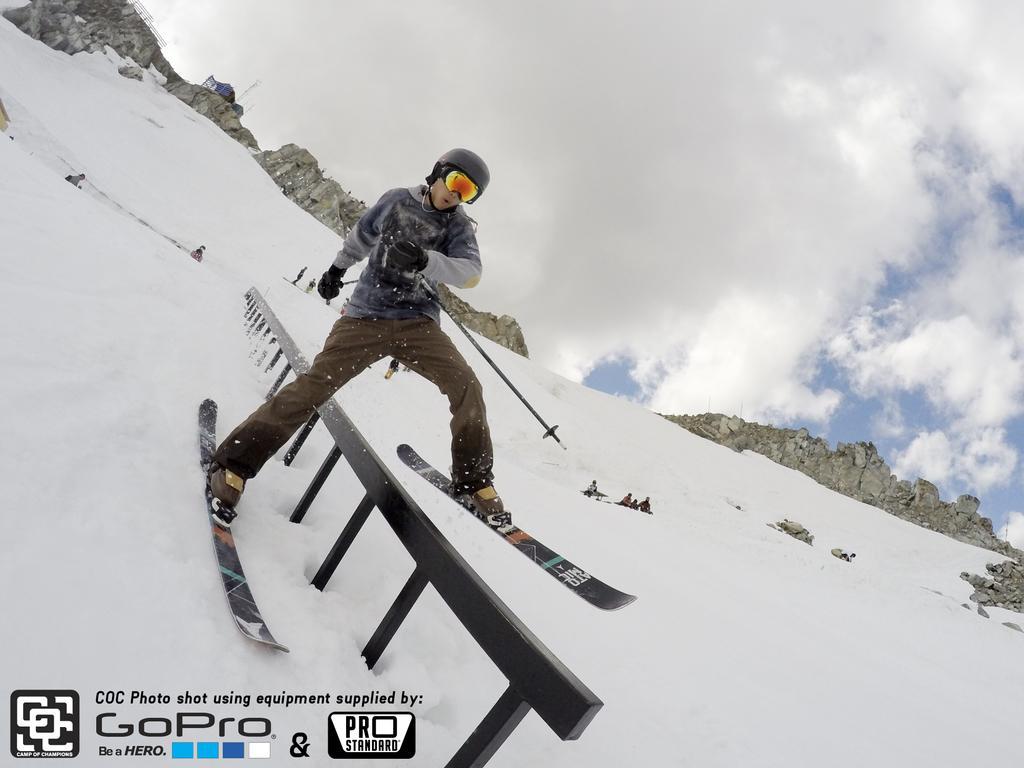Please provide a concise description of this image. Here we can see a person skating on the ice with ski boards on his legs, behind him we can see people here and there, the hill is snowy and the sky is cloudy 